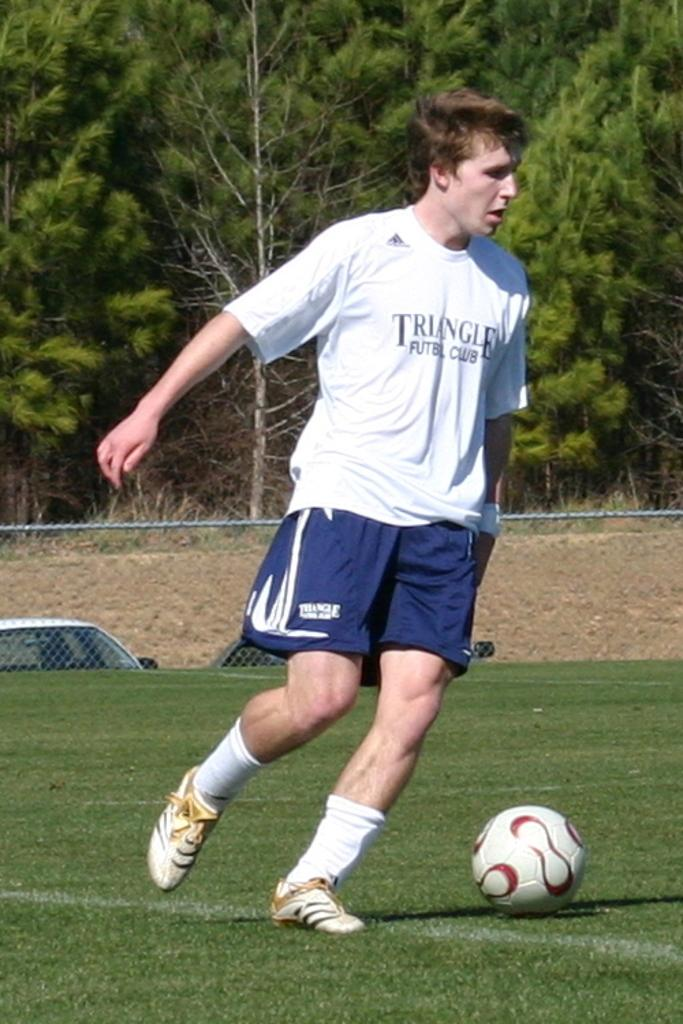<image>
Describe the image concisely. the word triangle is on the shirt the person is wearing 